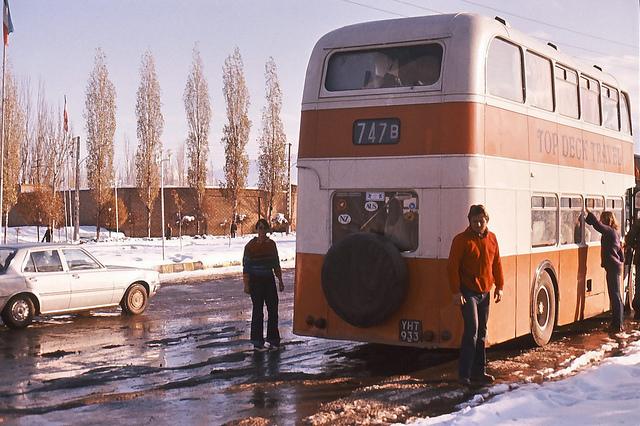What number is on the verse?
Keep it brief. 747. Is there a spare tire on the bus?
Be succinct. Yes. What is the season of the year?
Keep it brief. Winter. 